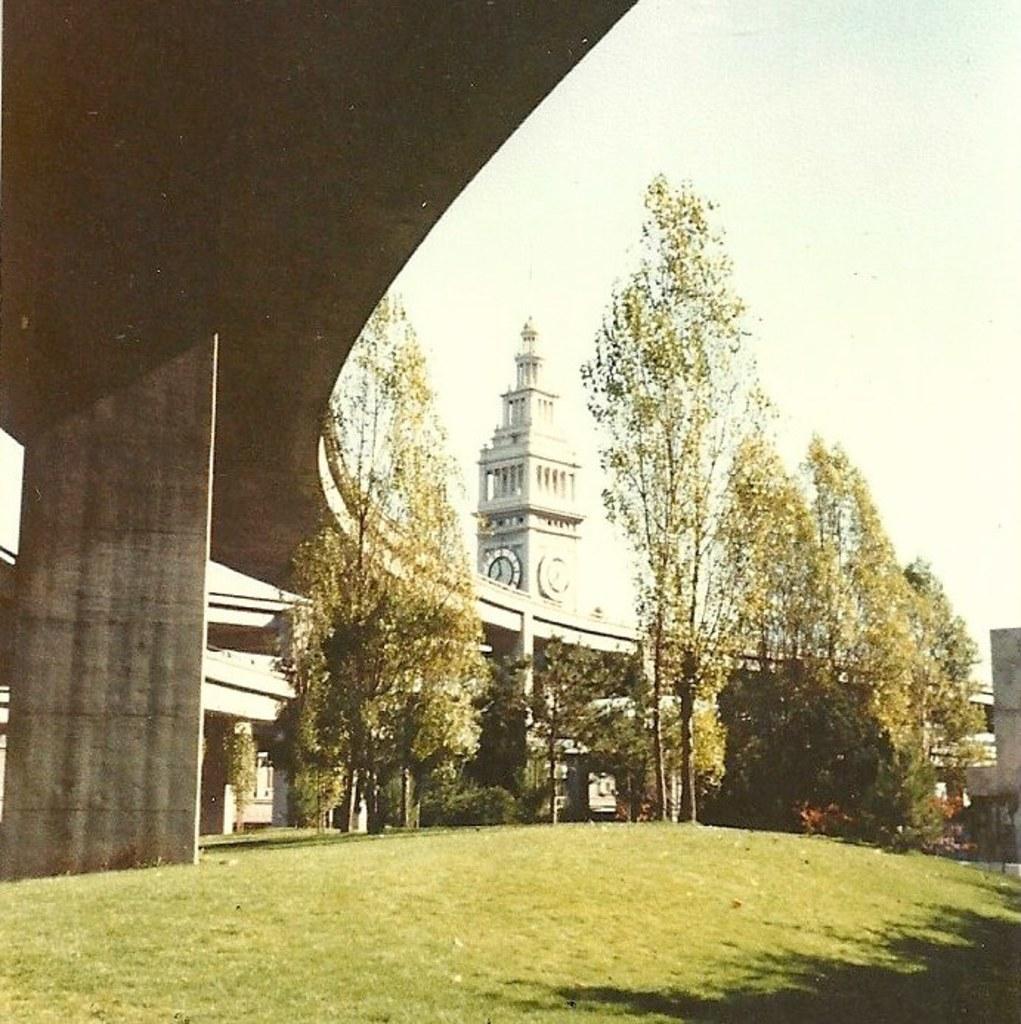Please provide a concise description of this image. In this picture there is a greenery ground and there is a bridge above it and there are trees and a clock tower in the background. 